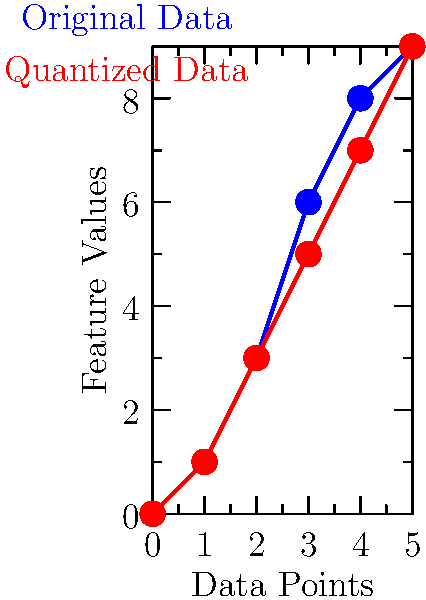In the context of vector quantization for compressing large legal databases, the graph shows original data points (blue) and their quantized representation (red). If the original data consists of 1000 6-dimensional vectors and is quantized to 64 codewords, what is the compression ratio achieved? To calculate the compression ratio, we need to follow these steps:

1. Calculate the original data size:
   - Each vector has 6 dimensions
   - There are 1000 vectors
   - Assuming each dimension is represented by a 32-bit float
   Original size = $1000 \times 6 \times 32$ bits = $192,000$ bits

2. Calculate the quantized data size:
   - We need to store the codebook: $64 \times 6 \times 32$ bits = $12,288$ bits
   - We need to store the index for each vector: $1000 \times \log_2(64)$ bits = $6,000$ bits
   Quantized size = $12,288 + 6,000 = 18,288$ bits

3. Calculate the compression ratio:
   Compression ratio = $\frac{\text{Original size}}{\text{Quantized size}} = \frac{192,000}{18,288} \approx 10.5$

Thus, the compression ratio achieved is approximately 10.5:1.
Answer: 10.5:1 